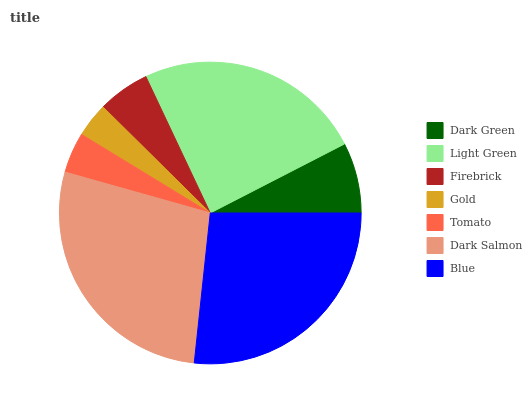Is Gold the minimum?
Answer yes or no. Yes. Is Dark Salmon the maximum?
Answer yes or no. Yes. Is Light Green the minimum?
Answer yes or no. No. Is Light Green the maximum?
Answer yes or no. No. Is Light Green greater than Dark Green?
Answer yes or no. Yes. Is Dark Green less than Light Green?
Answer yes or no. Yes. Is Dark Green greater than Light Green?
Answer yes or no. No. Is Light Green less than Dark Green?
Answer yes or no. No. Is Dark Green the high median?
Answer yes or no. Yes. Is Dark Green the low median?
Answer yes or no. Yes. Is Blue the high median?
Answer yes or no. No. Is Tomato the low median?
Answer yes or no. No. 